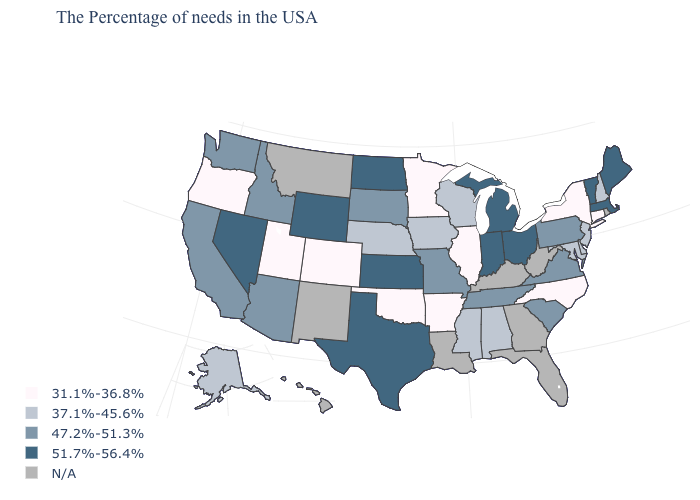Name the states that have a value in the range 47.2%-51.3%?
Be succinct. Pennsylvania, Virginia, South Carolina, Tennessee, Missouri, South Dakota, Arizona, Idaho, California, Washington. How many symbols are there in the legend?
Write a very short answer. 5. Name the states that have a value in the range 31.1%-36.8%?
Write a very short answer. Connecticut, New York, North Carolina, Illinois, Arkansas, Minnesota, Oklahoma, Colorado, Utah, Oregon. What is the value of Georgia?
Concise answer only. N/A. What is the lowest value in the Northeast?
Answer briefly. 31.1%-36.8%. Does Texas have the lowest value in the South?
Give a very brief answer. No. What is the value of Nebraska?
Write a very short answer. 37.1%-45.6%. Is the legend a continuous bar?
Write a very short answer. No. Name the states that have a value in the range 31.1%-36.8%?
Short answer required. Connecticut, New York, North Carolina, Illinois, Arkansas, Minnesota, Oklahoma, Colorado, Utah, Oregon. What is the value of Georgia?
Be succinct. N/A. What is the value of Idaho?
Give a very brief answer. 47.2%-51.3%. Which states have the highest value in the USA?
Keep it brief. Maine, Massachusetts, Vermont, Ohio, Michigan, Indiana, Kansas, Texas, North Dakota, Wyoming, Nevada. 